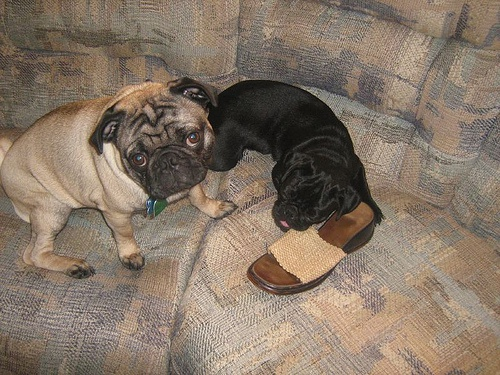Describe the objects in this image and their specific colors. I can see couch in gray and darkgray tones, dog in gray and tan tones, and dog in gray and black tones in this image. 